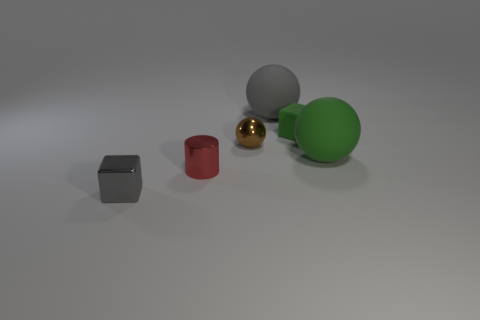What material is the object that is the same color as the rubber block?
Ensure brevity in your answer.  Rubber. Is the shape of the brown thing that is on the left side of the tiny green rubber object the same as the gray object that is right of the tiny shiny cube?
Provide a short and direct response. Yes. There is a green object that is the same size as the gray shiny thing; what is its material?
Your answer should be very brief. Rubber. Are the cube to the right of the gray shiny object and the gray object that is behind the brown sphere made of the same material?
Make the answer very short. Yes. There is a gray thing that is the same size as the metallic sphere; what shape is it?
Provide a short and direct response. Cube. How many other things are there of the same color as the shiny block?
Offer a terse response. 1. There is a cube that is right of the tiny gray shiny thing; what is its color?
Make the answer very short. Green. How many other objects are the same material as the tiny brown thing?
Give a very brief answer. 2. Is the number of green objects that are on the right side of the small red cylinder greater than the number of brown shiny things in front of the tiny gray shiny thing?
Offer a very short reply. Yes. How many gray objects are right of the gray shiny thing?
Provide a succinct answer. 1. 